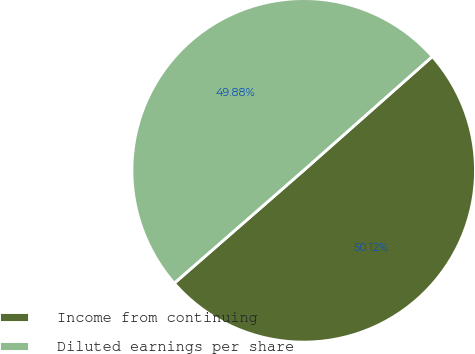<chart> <loc_0><loc_0><loc_500><loc_500><pie_chart><fcel>Income from continuing<fcel>Diluted earnings per share<nl><fcel>50.12%<fcel>49.88%<nl></chart> 